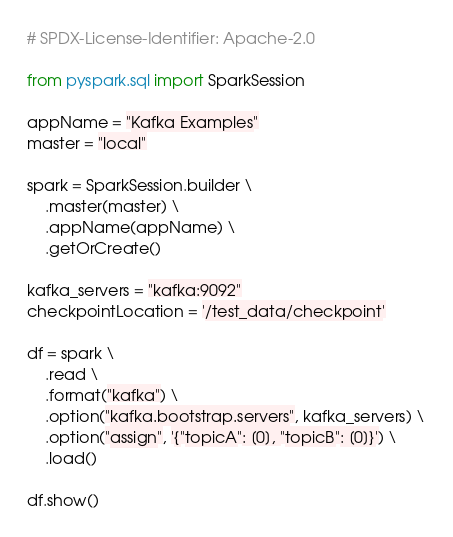Convert code to text. <code><loc_0><loc_0><loc_500><loc_500><_Python_># SPDX-License-Identifier: Apache-2.0

from pyspark.sql import SparkSession

appName = "Kafka Examples"
master = "local"

spark = SparkSession.builder \
    .master(master) \
    .appName(appName) \
    .getOrCreate()

kafka_servers = "kafka:9092"
checkpointLocation = '/test_data/checkpoint'

df = spark \
    .read \
    .format("kafka") \
    .option("kafka.bootstrap.servers", kafka_servers) \
    .option("assign", '{"topicA": [0], "topicB": [0]}') \
    .load()

df.show()
</code> 